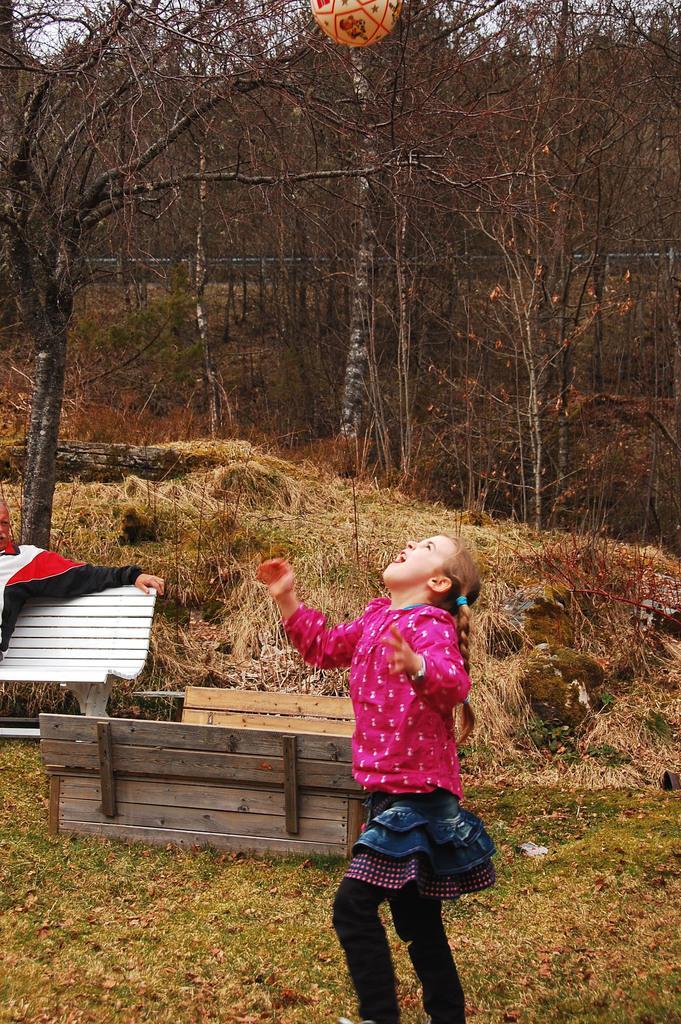Describe this image in one or two sentences. In this image i can see girl standing and looking up at the back ground i can see a bench, a tree and a sky. 